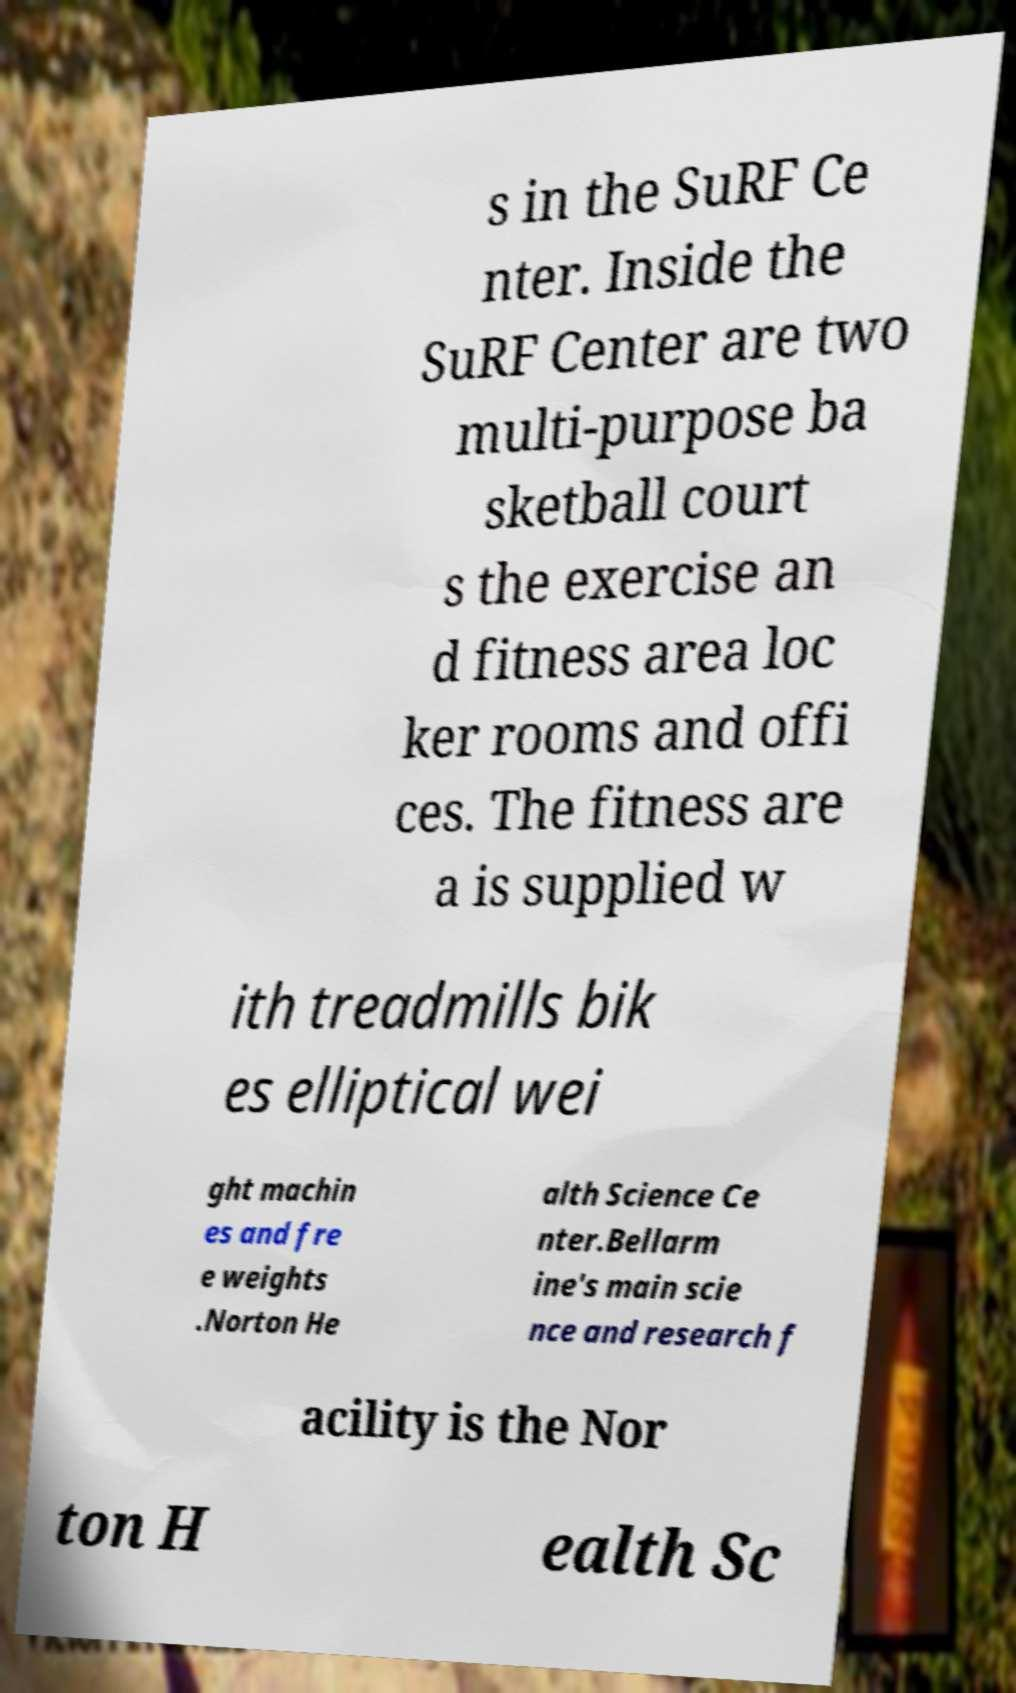Can you read and provide the text displayed in the image?This photo seems to have some interesting text. Can you extract and type it out for me? s in the SuRF Ce nter. Inside the SuRF Center are two multi-purpose ba sketball court s the exercise an d fitness area loc ker rooms and offi ces. The fitness are a is supplied w ith treadmills bik es elliptical wei ght machin es and fre e weights .Norton He alth Science Ce nter.Bellarm ine's main scie nce and research f acility is the Nor ton H ealth Sc 